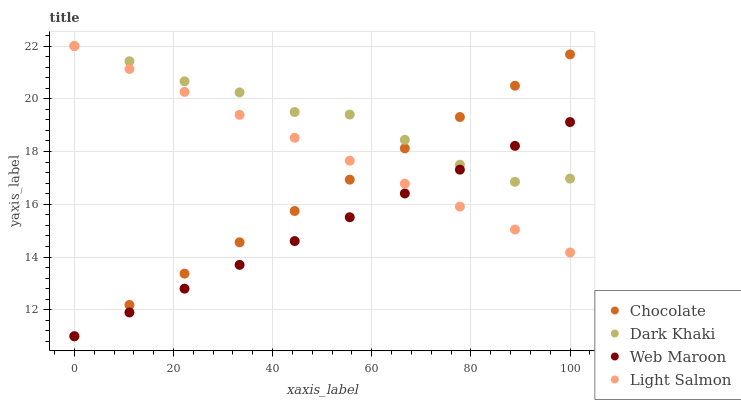Does Web Maroon have the minimum area under the curve?
Answer yes or no. Yes. Does Dark Khaki have the maximum area under the curve?
Answer yes or no. Yes. Does Light Salmon have the minimum area under the curve?
Answer yes or no. No. Does Light Salmon have the maximum area under the curve?
Answer yes or no. No. Is Web Maroon the smoothest?
Answer yes or no. Yes. Is Dark Khaki the roughest?
Answer yes or no. Yes. Is Light Salmon the smoothest?
Answer yes or no. No. Is Light Salmon the roughest?
Answer yes or no. No. Does Web Maroon have the lowest value?
Answer yes or no. Yes. Does Light Salmon have the lowest value?
Answer yes or no. No. Does Light Salmon have the highest value?
Answer yes or no. Yes. Does Web Maroon have the highest value?
Answer yes or no. No. Does Dark Khaki intersect Light Salmon?
Answer yes or no. Yes. Is Dark Khaki less than Light Salmon?
Answer yes or no. No. Is Dark Khaki greater than Light Salmon?
Answer yes or no. No. 